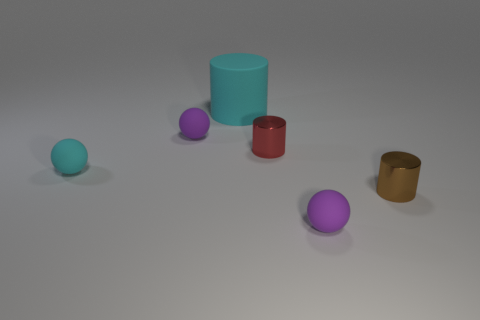The tiny object that is right of the tiny purple matte object that is to the right of the purple ball to the left of the big cyan thing is made of what material?
Offer a very short reply. Metal. How many other objects are the same size as the matte cylinder?
Your answer should be very brief. 0. What is the size of the thing that is the same color as the large rubber cylinder?
Ensure brevity in your answer.  Small. Is the number of matte cylinders that are in front of the big rubber thing greater than the number of gray cylinders?
Provide a succinct answer. No. Are there any tiny shiny spheres of the same color as the big matte thing?
Offer a terse response. No. There is another metal object that is the same size as the brown metal thing; what color is it?
Your answer should be compact. Red. There is a red cylinder in front of the big cyan cylinder; how many tiny matte spheres are right of it?
Your answer should be very brief. 1. What number of objects are either matte things that are behind the tiny cyan sphere or large cyan things?
Provide a short and direct response. 2. What number of big cyan things have the same material as the red thing?
Offer a terse response. 0. There is another object that is the same color as the big rubber object; what shape is it?
Give a very brief answer. Sphere. 